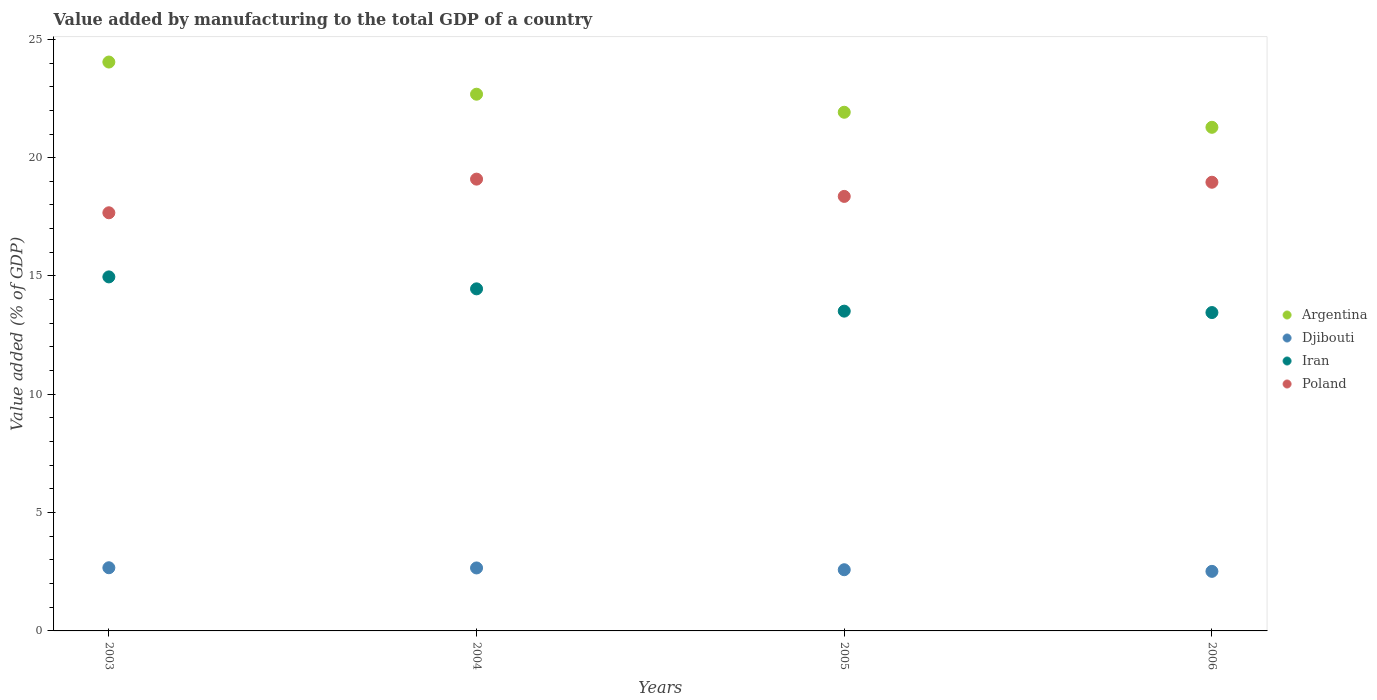What is the value added by manufacturing to the total GDP in Iran in 2006?
Keep it short and to the point. 13.45. Across all years, what is the maximum value added by manufacturing to the total GDP in Argentina?
Give a very brief answer. 24.04. Across all years, what is the minimum value added by manufacturing to the total GDP in Argentina?
Give a very brief answer. 21.28. What is the total value added by manufacturing to the total GDP in Argentina in the graph?
Keep it short and to the point. 89.93. What is the difference between the value added by manufacturing to the total GDP in Iran in 2004 and that in 2005?
Provide a short and direct response. 0.94. What is the difference between the value added by manufacturing to the total GDP in Poland in 2006 and the value added by manufacturing to the total GDP in Iran in 2003?
Your answer should be compact. 4. What is the average value added by manufacturing to the total GDP in Poland per year?
Provide a succinct answer. 18.52. In the year 2003, what is the difference between the value added by manufacturing to the total GDP in Poland and value added by manufacturing to the total GDP in Argentina?
Keep it short and to the point. -6.37. What is the ratio of the value added by manufacturing to the total GDP in Iran in 2005 to that in 2006?
Give a very brief answer. 1. What is the difference between the highest and the second highest value added by manufacturing to the total GDP in Iran?
Make the answer very short. 0.51. What is the difference between the highest and the lowest value added by manufacturing to the total GDP in Argentina?
Offer a terse response. 2.76. Does the value added by manufacturing to the total GDP in Poland monotonically increase over the years?
Provide a short and direct response. No. Is the value added by manufacturing to the total GDP in Argentina strictly greater than the value added by manufacturing to the total GDP in Iran over the years?
Offer a very short reply. Yes. Is the value added by manufacturing to the total GDP in Argentina strictly less than the value added by manufacturing to the total GDP in Djibouti over the years?
Provide a short and direct response. No. How many dotlines are there?
Offer a terse response. 4. Are the values on the major ticks of Y-axis written in scientific E-notation?
Offer a terse response. No. How are the legend labels stacked?
Your answer should be very brief. Vertical. What is the title of the graph?
Keep it short and to the point. Value added by manufacturing to the total GDP of a country. What is the label or title of the Y-axis?
Your answer should be very brief. Value added (% of GDP). What is the Value added (% of GDP) of Argentina in 2003?
Your answer should be very brief. 24.04. What is the Value added (% of GDP) in Djibouti in 2003?
Give a very brief answer. 2.67. What is the Value added (% of GDP) in Iran in 2003?
Offer a very short reply. 14.96. What is the Value added (% of GDP) of Poland in 2003?
Provide a succinct answer. 17.67. What is the Value added (% of GDP) in Argentina in 2004?
Your answer should be very brief. 22.68. What is the Value added (% of GDP) in Djibouti in 2004?
Your answer should be compact. 2.66. What is the Value added (% of GDP) in Iran in 2004?
Make the answer very short. 14.46. What is the Value added (% of GDP) of Poland in 2004?
Offer a very short reply. 19.09. What is the Value added (% of GDP) in Argentina in 2005?
Ensure brevity in your answer.  21.92. What is the Value added (% of GDP) of Djibouti in 2005?
Your answer should be very brief. 2.59. What is the Value added (% of GDP) in Iran in 2005?
Your answer should be compact. 13.51. What is the Value added (% of GDP) of Poland in 2005?
Ensure brevity in your answer.  18.36. What is the Value added (% of GDP) in Argentina in 2006?
Provide a short and direct response. 21.28. What is the Value added (% of GDP) in Djibouti in 2006?
Your answer should be very brief. 2.52. What is the Value added (% of GDP) in Iran in 2006?
Provide a succinct answer. 13.45. What is the Value added (% of GDP) in Poland in 2006?
Your answer should be very brief. 18.96. Across all years, what is the maximum Value added (% of GDP) of Argentina?
Your response must be concise. 24.04. Across all years, what is the maximum Value added (% of GDP) in Djibouti?
Keep it short and to the point. 2.67. Across all years, what is the maximum Value added (% of GDP) in Iran?
Your answer should be very brief. 14.96. Across all years, what is the maximum Value added (% of GDP) in Poland?
Your response must be concise. 19.09. Across all years, what is the minimum Value added (% of GDP) in Argentina?
Offer a terse response. 21.28. Across all years, what is the minimum Value added (% of GDP) of Djibouti?
Give a very brief answer. 2.52. Across all years, what is the minimum Value added (% of GDP) of Iran?
Your response must be concise. 13.45. Across all years, what is the minimum Value added (% of GDP) in Poland?
Your answer should be compact. 17.67. What is the total Value added (% of GDP) of Argentina in the graph?
Make the answer very short. 89.93. What is the total Value added (% of GDP) in Djibouti in the graph?
Ensure brevity in your answer.  10.43. What is the total Value added (% of GDP) in Iran in the graph?
Offer a terse response. 56.39. What is the total Value added (% of GDP) in Poland in the graph?
Offer a very short reply. 74.09. What is the difference between the Value added (% of GDP) in Argentina in 2003 and that in 2004?
Give a very brief answer. 1.36. What is the difference between the Value added (% of GDP) in Djibouti in 2003 and that in 2004?
Offer a terse response. 0.01. What is the difference between the Value added (% of GDP) in Iran in 2003 and that in 2004?
Ensure brevity in your answer.  0.51. What is the difference between the Value added (% of GDP) of Poland in 2003 and that in 2004?
Give a very brief answer. -1.42. What is the difference between the Value added (% of GDP) in Argentina in 2003 and that in 2005?
Make the answer very short. 2.12. What is the difference between the Value added (% of GDP) of Djibouti in 2003 and that in 2005?
Keep it short and to the point. 0.08. What is the difference between the Value added (% of GDP) in Iran in 2003 and that in 2005?
Provide a succinct answer. 1.45. What is the difference between the Value added (% of GDP) in Poland in 2003 and that in 2005?
Offer a terse response. -0.69. What is the difference between the Value added (% of GDP) in Argentina in 2003 and that in 2006?
Ensure brevity in your answer.  2.76. What is the difference between the Value added (% of GDP) of Djibouti in 2003 and that in 2006?
Your answer should be very brief. 0.15. What is the difference between the Value added (% of GDP) of Iran in 2003 and that in 2006?
Provide a short and direct response. 1.51. What is the difference between the Value added (% of GDP) of Poland in 2003 and that in 2006?
Ensure brevity in your answer.  -1.29. What is the difference between the Value added (% of GDP) in Argentina in 2004 and that in 2005?
Make the answer very short. 0.76. What is the difference between the Value added (% of GDP) in Djibouti in 2004 and that in 2005?
Your response must be concise. 0.08. What is the difference between the Value added (% of GDP) in Iran in 2004 and that in 2005?
Your response must be concise. 0.94. What is the difference between the Value added (% of GDP) of Poland in 2004 and that in 2005?
Keep it short and to the point. 0.73. What is the difference between the Value added (% of GDP) of Argentina in 2004 and that in 2006?
Ensure brevity in your answer.  1.4. What is the difference between the Value added (% of GDP) in Djibouti in 2004 and that in 2006?
Offer a very short reply. 0.14. What is the difference between the Value added (% of GDP) in Poland in 2004 and that in 2006?
Give a very brief answer. 0.13. What is the difference between the Value added (% of GDP) in Argentina in 2005 and that in 2006?
Your response must be concise. 0.64. What is the difference between the Value added (% of GDP) in Djibouti in 2005 and that in 2006?
Keep it short and to the point. 0.07. What is the difference between the Value added (% of GDP) in Iran in 2005 and that in 2006?
Provide a short and direct response. 0.06. What is the difference between the Value added (% of GDP) in Poland in 2005 and that in 2006?
Your answer should be very brief. -0.6. What is the difference between the Value added (% of GDP) in Argentina in 2003 and the Value added (% of GDP) in Djibouti in 2004?
Ensure brevity in your answer.  21.38. What is the difference between the Value added (% of GDP) in Argentina in 2003 and the Value added (% of GDP) in Iran in 2004?
Keep it short and to the point. 9.59. What is the difference between the Value added (% of GDP) of Argentina in 2003 and the Value added (% of GDP) of Poland in 2004?
Provide a succinct answer. 4.95. What is the difference between the Value added (% of GDP) of Djibouti in 2003 and the Value added (% of GDP) of Iran in 2004?
Offer a terse response. -11.79. What is the difference between the Value added (% of GDP) of Djibouti in 2003 and the Value added (% of GDP) of Poland in 2004?
Your answer should be very brief. -16.42. What is the difference between the Value added (% of GDP) of Iran in 2003 and the Value added (% of GDP) of Poland in 2004?
Keep it short and to the point. -4.13. What is the difference between the Value added (% of GDP) in Argentina in 2003 and the Value added (% of GDP) in Djibouti in 2005?
Your answer should be very brief. 21.46. What is the difference between the Value added (% of GDP) of Argentina in 2003 and the Value added (% of GDP) of Iran in 2005?
Your response must be concise. 10.53. What is the difference between the Value added (% of GDP) in Argentina in 2003 and the Value added (% of GDP) in Poland in 2005?
Offer a very short reply. 5.68. What is the difference between the Value added (% of GDP) of Djibouti in 2003 and the Value added (% of GDP) of Iran in 2005?
Give a very brief answer. -10.84. What is the difference between the Value added (% of GDP) of Djibouti in 2003 and the Value added (% of GDP) of Poland in 2005?
Your answer should be very brief. -15.69. What is the difference between the Value added (% of GDP) of Iran in 2003 and the Value added (% of GDP) of Poland in 2005?
Your answer should be very brief. -3.4. What is the difference between the Value added (% of GDP) of Argentina in 2003 and the Value added (% of GDP) of Djibouti in 2006?
Your response must be concise. 21.52. What is the difference between the Value added (% of GDP) in Argentina in 2003 and the Value added (% of GDP) in Iran in 2006?
Keep it short and to the point. 10.59. What is the difference between the Value added (% of GDP) in Argentina in 2003 and the Value added (% of GDP) in Poland in 2006?
Make the answer very short. 5.08. What is the difference between the Value added (% of GDP) of Djibouti in 2003 and the Value added (% of GDP) of Iran in 2006?
Your response must be concise. -10.78. What is the difference between the Value added (% of GDP) of Djibouti in 2003 and the Value added (% of GDP) of Poland in 2006?
Provide a succinct answer. -16.29. What is the difference between the Value added (% of GDP) of Iran in 2003 and the Value added (% of GDP) of Poland in 2006?
Keep it short and to the point. -4. What is the difference between the Value added (% of GDP) of Argentina in 2004 and the Value added (% of GDP) of Djibouti in 2005?
Give a very brief answer. 20.1. What is the difference between the Value added (% of GDP) in Argentina in 2004 and the Value added (% of GDP) in Iran in 2005?
Offer a very short reply. 9.17. What is the difference between the Value added (% of GDP) in Argentina in 2004 and the Value added (% of GDP) in Poland in 2005?
Offer a very short reply. 4.32. What is the difference between the Value added (% of GDP) in Djibouti in 2004 and the Value added (% of GDP) in Iran in 2005?
Provide a short and direct response. -10.85. What is the difference between the Value added (% of GDP) of Djibouti in 2004 and the Value added (% of GDP) of Poland in 2005?
Offer a terse response. -15.7. What is the difference between the Value added (% of GDP) of Iran in 2004 and the Value added (% of GDP) of Poland in 2005?
Provide a short and direct response. -3.91. What is the difference between the Value added (% of GDP) of Argentina in 2004 and the Value added (% of GDP) of Djibouti in 2006?
Your response must be concise. 20.17. What is the difference between the Value added (% of GDP) in Argentina in 2004 and the Value added (% of GDP) in Iran in 2006?
Provide a short and direct response. 9.23. What is the difference between the Value added (% of GDP) of Argentina in 2004 and the Value added (% of GDP) of Poland in 2006?
Offer a terse response. 3.72. What is the difference between the Value added (% of GDP) of Djibouti in 2004 and the Value added (% of GDP) of Iran in 2006?
Keep it short and to the point. -10.79. What is the difference between the Value added (% of GDP) in Djibouti in 2004 and the Value added (% of GDP) in Poland in 2006?
Offer a very short reply. -16.3. What is the difference between the Value added (% of GDP) in Iran in 2004 and the Value added (% of GDP) in Poland in 2006?
Your response must be concise. -4.51. What is the difference between the Value added (% of GDP) of Argentina in 2005 and the Value added (% of GDP) of Djibouti in 2006?
Your answer should be compact. 19.4. What is the difference between the Value added (% of GDP) of Argentina in 2005 and the Value added (% of GDP) of Iran in 2006?
Make the answer very short. 8.46. What is the difference between the Value added (% of GDP) of Argentina in 2005 and the Value added (% of GDP) of Poland in 2006?
Ensure brevity in your answer.  2.96. What is the difference between the Value added (% of GDP) of Djibouti in 2005 and the Value added (% of GDP) of Iran in 2006?
Provide a succinct answer. -10.87. What is the difference between the Value added (% of GDP) in Djibouti in 2005 and the Value added (% of GDP) in Poland in 2006?
Your response must be concise. -16.38. What is the difference between the Value added (% of GDP) of Iran in 2005 and the Value added (% of GDP) of Poland in 2006?
Your answer should be very brief. -5.45. What is the average Value added (% of GDP) of Argentina per year?
Your response must be concise. 22.48. What is the average Value added (% of GDP) in Djibouti per year?
Your answer should be very brief. 2.61. What is the average Value added (% of GDP) in Iran per year?
Make the answer very short. 14.1. What is the average Value added (% of GDP) in Poland per year?
Offer a terse response. 18.52. In the year 2003, what is the difference between the Value added (% of GDP) in Argentina and Value added (% of GDP) in Djibouti?
Your answer should be very brief. 21.37. In the year 2003, what is the difference between the Value added (% of GDP) of Argentina and Value added (% of GDP) of Iran?
Your answer should be very brief. 9.08. In the year 2003, what is the difference between the Value added (% of GDP) of Argentina and Value added (% of GDP) of Poland?
Provide a short and direct response. 6.37. In the year 2003, what is the difference between the Value added (% of GDP) in Djibouti and Value added (% of GDP) in Iran?
Offer a terse response. -12.29. In the year 2003, what is the difference between the Value added (% of GDP) in Djibouti and Value added (% of GDP) in Poland?
Your response must be concise. -15. In the year 2003, what is the difference between the Value added (% of GDP) in Iran and Value added (% of GDP) in Poland?
Offer a terse response. -2.71. In the year 2004, what is the difference between the Value added (% of GDP) in Argentina and Value added (% of GDP) in Djibouti?
Give a very brief answer. 20.02. In the year 2004, what is the difference between the Value added (% of GDP) of Argentina and Value added (% of GDP) of Iran?
Provide a succinct answer. 8.23. In the year 2004, what is the difference between the Value added (% of GDP) of Argentina and Value added (% of GDP) of Poland?
Keep it short and to the point. 3.59. In the year 2004, what is the difference between the Value added (% of GDP) of Djibouti and Value added (% of GDP) of Iran?
Your answer should be very brief. -11.8. In the year 2004, what is the difference between the Value added (% of GDP) in Djibouti and Value added (% of GDP) in Poland?
Provide a short and direct response. -16.43. In the year 2004, what is the difference between the Value added (% of GDP) of Iran and Value added (% of GDP) of Poland?
Give a very brief answer. -4.64. In the year 2005, what is the difference between the Value added (% of GDP) of Argentina and Value added (% of GDP) of Djibouti?
Your answer should be very brief. 19.33. In the year 2005, what is the difference between the Value added (% of GDP) of Argentina and Value added (% of GDP) of Iran?
Your response must be concise. 8.41. In the year 2005, what is the difference between the Value added (% of GDP) in Argentina and Value added (% of GDP) in Poland?
Provide a succinct answer. 3.56. In the year 2005, what is the difference between the Value added (% of GDP) of Djibouti and Value added (% of GDP) of Iran?
Your response must be concise. -10.93. In the year 2005, what is the difference between the Value added (% of GDP) in Djibouti and Value added (% of GDP) in Poland?
Your answer should be very brief. -15.78. In the year 2005, what is the difference between the Value added (% of GDP) of Iran and Value added (% of GDP) of Poland?
Ensure brevity in your answer.  -4.85. In the year 2006, what is the difference between the Value added (% of GDP) of Argentina and Value added (% of GDP) of Djibouti?
Offer a terse response. 18.77. In the year 2006, what is the difference between the Value added (% of GDP) of Argentina and Value added (% of GDP) of Iran?
Keep it short and to the point. 7.83. In the year 2006, what is the difference between the Value added (% of GDP) in Argentina and Value added (% of GDP) in Poland?
Provide a short and direct response. 2.32. In the year 2006, what is the difference between the Value added (% of GDP) of Djibouti and Value added (% of GDP) of Iran?
Give a very brief answer. -10.94. In the year 2006, what is the difference between the Value added (% of GDP) of Djibouti and Value added (% of GDP) of Poland?
Your response must be concise. -16.44. In the year 2006, what is the difference between the Value added (% of GDP) of Iran and Value added (% of GDP) of Poland?
Your answer should be compact. -5.51. What is the ratio of the Value added (% of GDP) of Argentina in 2003 to that in 2004?
Ensure brevity in your answer.  1.06. What is the ratio of the Value added (% of GDP) in Djibouti in 2003 to that in 2004?
Give a very brief answer. 1. What is the ratio of the Value added (% of GDP) of Iran in 2003 to that in 2004?
Provide a short and direct response. 1.03. What is the ratio of the Value added (% of GDP) of Poland in 2003 to that in 2004?
Your answer should be compact. 0.93. What is the ratio of the Value added (% of GDP) in Argentina in 2003 to that in 2005?
Provide a short and direct response. 1.1. What is the ratio of the Value added (% of GDP) of Djibouti in 2003 to that in 2005?
Keep it short and to the point. 1.03. What is the ratio of the Value added (% of GDP) in Iran in 2003 to that in 2005?
Make the answer very short. 1.11. What is the ratio of the Value added (% of GDP) of Poland in 2003 to that in 2005?
Keep it short and to the point. 0.96. What is the ratio of the Value added (% of GDP) in Argentina in 2003 to that in 2006?
Offer a terse response. 1.13. What is the ratio of the Value added (% of GDP) of Djibouti in 2003 to that in 2006?
Offer a terse response. 1.06. What is the ratio of the Value added (% of GDP) of Iran in 2003 to that in 2006?
Your answer should be compact. 1.11. What is the ratio of the Value added (% of GDP) of Poland in 2003 to that in 2006?
Give a very brief answer. 0.93. What is the ratio of the Value added (% of GDP) in Argentina in 2004 to that in 2005?
Offer a very short reply. 1.03. What is the ratio of the Value added (% of GDP) of Djibouti in 2004 to that in 2005?
Offer a terse response. 1.03. What is the ratio of the Value added (% of GDP) in Iran in 2004 to that in 2005?
Your answer should be compact. 1.07. What is the ratio of the Value added (% of GDP) of Poland in 2004 to that in 2005?
Give a very brief answer. 1.04. What is the ratio of the Value added (% of GDP) of Argentina in 2004 to that in 2006?
Your answer should be compact. 1.07. What is the ratio of the Value added (% of GDP) of Djibouti in 2004 to that in 2006?
Offer a very short reply. 1.06. What is the ratio of the Value added (% of GDP) of Iran in 2004 to that in 2006?
Offer a very short reply. 1.07. What is the ratio of the Value added (% of GDP) in Poland in 2004 to that in 2006?
Offer a very short reply. 1.01. What is the ratio of the Value added (% of GDP) of Argentina in 2005 to that in 2006?
Provide a short and direct response. 1.03. What is the ratio of the Value added (% of GDP) of Djibouti in 2005 to that in 2006?
Offer a terse response. 1.03. What is the ratio of the Value added (% of GDP) of Iran in 2005 to that in 2006?
Provide a short and direct response. 1. What is the ratio of the Value added (% of GDP) of Poland in 2005 to that in 2006?
Ensure brevity in your answer.  0.97. What is the difference between the highest and the second highest Value added (% of GDP) of Argentina?
Ensure brevity in your answer.  1.36. What is the difference between the highest and the second highest Value added (% of GDP) of Djibouti?
Ensure brevity in your answer.  0.01. What is the difference between the highest and the second highest Value added (% of GDP) in Iran?
Offer a terse response. 0.51. What is the difference between the highest and the second highest Value added (% of GDP) in Poland?
Your response must be concise. 0.13. What is the difference between the highest and the lowest Value added (% of GDP) of Argentina?
Offer a terse response. 2.76. What is the difference between the highest and the lowest Value added (% of GDP) in Djibouti?
Provide a succinct answer. 0.15. What is the difference between the highest and the lowest Value added (% of GDP) in Iran?
Your answer should be very brief. 1.51. What is the difference between the highest and the lowest Value added (% of GDP) in Poland?
Your response must be concise. 1.42. 